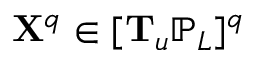Convert formula to latex. <formula><loc_0><loc_0><loc_500><loc_500>X ^ { q } \in [ T _ { \mathfrak { u } } \mathbb { P } _ { L } ] ^ { q }</formula> 